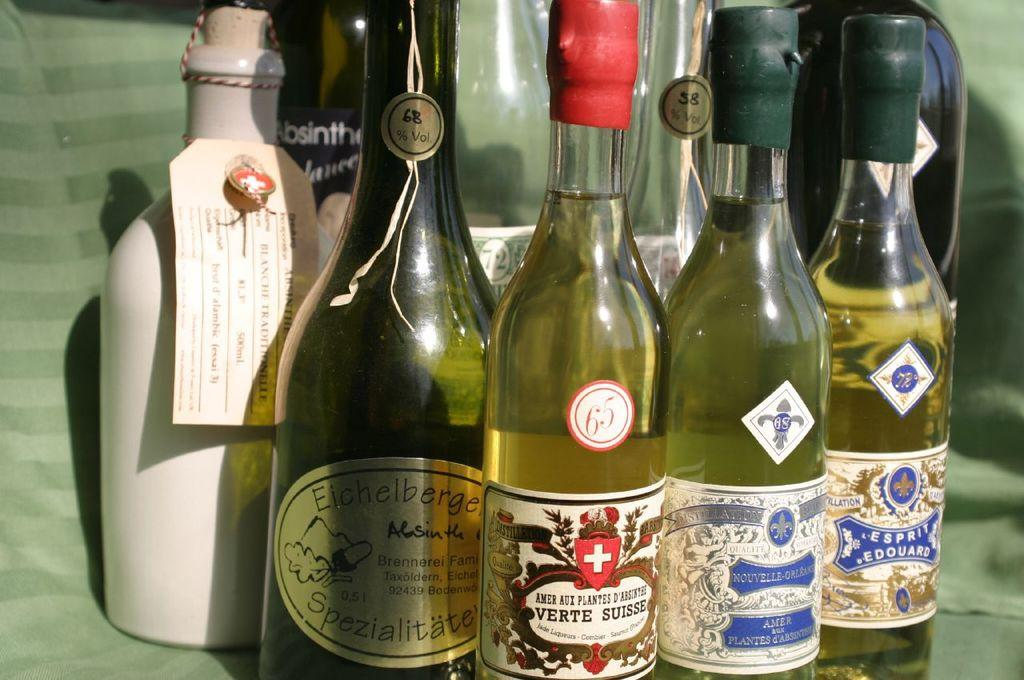<image>
Offer a succinct explanation of the picture presented. A bottle of Absinthe peeks behind a group of bottles. 